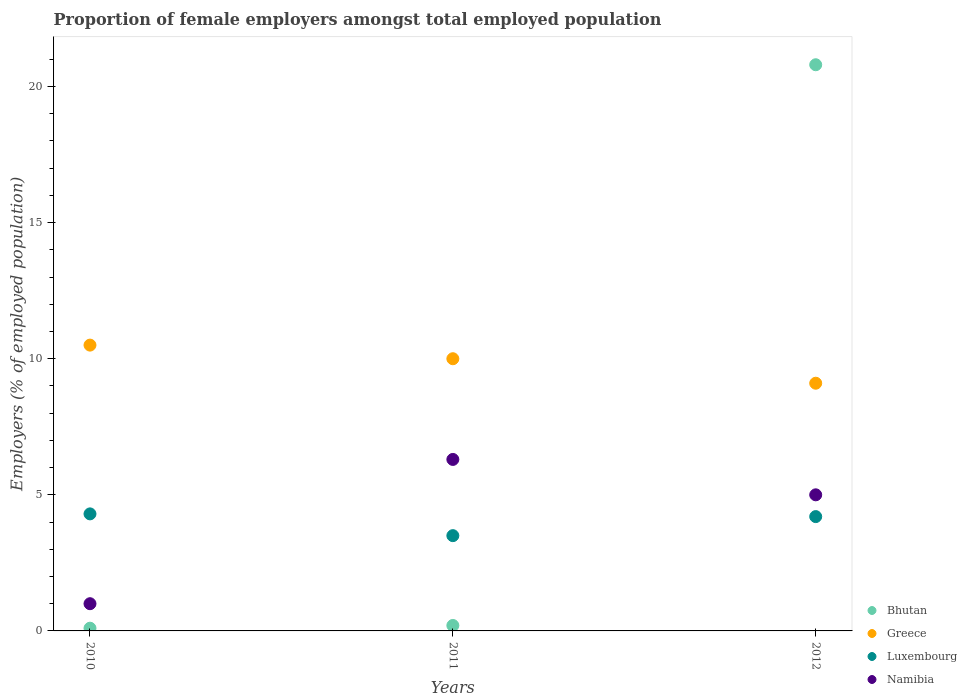How many different coloured dotlines are there?
Ensure brevity in your answer.  4. Is the number of dotlines equal to the number of legend labels?
Provide a short and direct response. Yes. What is the proportion of female employers in Namibia in 2011?
Offer a very short reply. 6.3. Across all years, what is the maximum proportion of female employers in Luxembourg?
Your answer should be compact. 4.3. Across all years, what is the minimum proportion of female employers in Greece?
Your answer should be compact. 9.1. What is the total proportion of female employers in Bhutan in the graph?
Your answer should be compact. 21.1. What is the difference between the proportion of female employers in Namibia in 2010 and that in 2012?
Keep it short and to the point. -4. What is the difference between the proportion of female employers in Namibia in 2011 and the proportion of female employers in Luxembourg in 2012?
Offer a terse response. 2.1. In the year 2012, what is the difference between the proportion of female employers in Luxembourg and proportion of female employers in Greece?
Provide a short and direct response. -4.9. In how many years, is the proportion of female employers in Luxembourg greater than 19 %?
Your response must be concise. 0. Is the proportion of female employers in Luxembourg in 2010 less than that in 2012?
Your response must be concise. No. Is the difference between the proportion of female employers in Luxembourg in 2011 and 2012 greater than the difference between the proportion of female employers in Greece in 2011 and 2012?
Offer a terse response. No. What is the difference between the highest and the second highest proportion of female employers in Namibia?
Offer a terse response. 1.3. What is the difference between the highest and the lowest proportion of female employers in Bhutan?
Give a very brief answer. 20.7. In how many years, is the proportion of female employers in Namibia greater than the average proportion of female employers in Namibia taken over all years?
Give a very brief answer. 2. Does the proportion of female employers in Luxembourg monotonically increase over the years?
Keep it short and to the point. No. How many years are there in the graph?
Make the answer very short. 3. Are the values on the major ticks of Y-axis written in scientific E-notation?
Keep it short and to the point. No. Does the graph contain any zero values?
Make the answer very short. No. Does the graph contain grids?
Ensure brevity in your answer.  No. Where does the legend appear in the graph?
Your answer should be compact. Bottom right. How many legend labels are there?
Provide a short and direct response. 4. What is the title of the graph?
Your response must be concise. Proportion of female employers amongst total employed population. Does "Latin America(all income levels)" appear as one of the legend labels in the graph?
Provide a short and direct response. No. What is the label or title of the X-axis?
Ensure brevity in your answer.  Years. What is the label or title of the Y-axis?
Your response must be concise. Employers (% of employed population). What is the Employers (% of employed population) of Bhutan in 2010?
Offer a very short reply. 0.1. What is the Employers (% of employed population) in Luxembourg in 2010?
Ensure brevity in your answer.  4.3. What is the Employers (% of employed population) of Bhutan in 2011?
Give a very brief answer. 0.2. What is the Employers (% of employed population) of Namibia in 2011?
Offer a very short reply. 6.3. What is the Employers (% of employed population) in Bhutan in 2012?
Provide a succinct answer. 20.8. What is the Employers (% of employed population) in Greece in 2012?
Your answer should be very brief. 9.1. What is the Employers (% of employed population) of Luxembourg in 2012?
Your response must be concise. 4.2. Across all years, what is the maximum Employers (% of employed population) in Bhutan?
Give a very brief answer. 20.8. Across all years, what is the maximum Employers (% of employed population) in Luxembourg?
Provide a succinct answer. 4.3. Across all years, what is the maximum Employers (% of employed population) in Namibia?
Make the answer very short. 6.3. Across all years, what is the minimum Employers (% of employed population) in Bhutan?
Your answer should be compact. 0.1. Across all years, what is the minimum Employers (% of employed population) of Greece?
Your answer should be very brief. 9.1. Across all years, what is the minimum Employers (% of employed population) of Namibia?
Make the answer very short. 1. What is the total Employers (% of employed population) in Bhutan in the graph?
Your response must be concise. 21.1. What is the total Employers (% of employed population) in Greece in the graph?
Ensure brevity in your answer.  29.6. What is the total Employers (% of employed population) in Namibia in the graph?
Provide a succinct answer. 12.3. What is the difference between the Employers (% of employed population) in Bhutan in 2010 and that in 2011?
Offer a terse response. -0.1. What is the difference between the Employers (% of employed population) in Bhutan in 2010 and that in 2012?
Offer a very short reply. -20.7. What is the difference between the Employers (% of employed population) of Greece in 2010 and that in 2012?
Your response must be concise. 1.4. What is the difference between the Employers (% of employed population) in Namibia in 2010 and that in 2012?
Your answer should be compact. -4. What is the difference between the Employers (% of employed population) of Bhutan in 2011 and that in 2012?
Make the answer very short. -20.6. What is the difference between the Employers (% of employed population) in Greece in 2011 and that in 2012?
Your response must be concise. 0.9. What is the difference between the Employers (% of employed population) in Luxembourg in 2011 and that in 2012?
Give a very brief answer. -0.7. What is the difference between the Employers (% of employed population) of Luxembourg in 2010 and the Employers (% of employed population) of Namibia in 2011?
Ensure brevity in your answer.  -2. What is the difference between the Employers (% of employed population) in Bhutan in 2010 and the Employers (% of employed population) in Greece in 2012?
Your answer should be compact. -9. What is the difference between the Employers (% of employed population) in Bhutan in 2010 and the Employers (% of employed population) in Namibia in 2012?
Your answer should be very brief. -4.9. What is the difference between the Employers (% of employed population) in Luxembourg in 2010 and the Employers (% of employed population) in Namibia in 2012?
Keep it short and to the point. -0.7. What is the difference between the Employers (% of employed population) of Bhutan in 2011 and the Employers (% of employed population) of Luxembourg in 2012?
Make the answer very short. -4. What is the difference between the Employers (% of employed population) of Bhutan in 2011 and the Employers (% of employed population) of Namibia in 2012?
Your answer should be very brief. -4.8. What is the difference between the Employers (% of employed population) in Luxembourg in 2011 and the Employers (% of employed population) in Namibia in 2012?
Ensure brevity in your answer.  -1.5. What is the average Employers (% of employed population) in Bhutan per year?
Provide a succinct answer. 7.03. What is the average Employers (% of employed population) of Greece per year?
Ensure brevity in your answer.  9.87. What is the average Employers (% of employed population) in Namibia per year?
Give a very brief answer. 4.1. In the year 2010, what is the difference between the Employers (% of employed population) of Bhutan and Employers (% of employed population) of Namibia?
Your answer should be very brief. -0.9. In the year 2010, what is the difference between the Employers (% of employed population) in Luxembourg and Employers (% of employed population) in Namibia?
Your response must be concise. 3.3. In the year 2011, what is the difference between the Employers (% of employed population) of Bhutan and Employers (% of employed population) of Luxembourg?
Make the answer very short. -3.3. In the year 2011, what is the difference between the Employers (% of employed population) of Greece and Employers (% of employed population) of Namibia?
Keep it short and to the point. 3.7. In the year 2012, what is the difference between the Employers (% of employed population) in Bhutan and Employers (% of employed population) in Greece?
Offer a very short reply. 11.7. In the year 2012, what is the difference between the Employers (% of employed population) in Bhutan and Employers (% of employed population) in Luxembourg?
Offer a terse response. 16.6. In the year 2012, what is the difference between the Employers (% of employed population) in Greece and Employers (% of employed population) in Luxembourg?
Your answer should be very brief. 4.9. What is the ratio of the Employers (% of employed population) of Greece in 2010 to that in 2011?
Make the answer very short. 1.05. What is the ratio of the Employers (% of employed population) of Luxembourg in 2010 to that in 2011?
Keep it short and to the point. 1.23. What is the ratio of the Employers (% of employed population) in Namibia in 2010 to that in 2011?
Offer a very short reply. 0.16. What is the ratio of the Employers (% of employed population) of Bhutan in 2010 to that in 2012?
Ensure brevity in your answer.  0. What is the ratio of the Employers (% of employed population) in Greece in 2010 to that in 2012?
Give a very brief answer. 1.15. What is the ratio of the Employers (% of employed population) in Luxembourg in 2010 to that in 2012?
Offer a terse response. 1.02. What is the ratio of the Employers (% of employed population) in Bhutan in 2011 to that in 2012?
Your response must be concise. 0.01. What is the ratio of the Employers (% of employed population) of Greece in 2011 to that in 2012?
Make the answer very short. 1.1. What is the ratio of the Employers (% of employed population) in Luxembourg in 2011 to that in 2012?
Make the answer very short. 0.83. What is the ratio of the Employers (% of employed population) of Namibia in 2011 to that in 2012?
Provide a succinct answer. 1.26. What is the difference between the highest and the second highest Employers (% of employed population) of Bhutan?
Provide a short and direct response. 20.6. What is the difference between the highest and the second highest Employers (% of employed population) of Luxembourg?
Keep it short and to the point. 0.1. What is the difference between the highest and the second highest Employers (% of employed population) in Namibia?
Offer a very short reply. 1.3. What is the difference between the highest and the lowest Employers (% of employed population) of Bhutan?
Your answer should be compact. 20.7. What is the difference between the highest and the lowest Employers (% of employed population) in Luxembourg?
Ensure brevity in your answer.  0.8. What is the difference between the highest and the lowest Employers (% of employed population) in Namibia?
Provide a succinct answer. 5.3. 